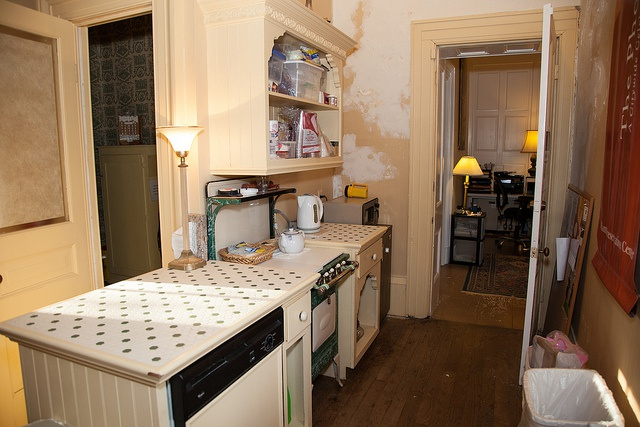Describe the objects in this image and their specific colors. I can see oven in gray and black tones, microwave in gray, black, and maroon tones, chair in gray, black, maroon, and darkgray tones, and bottle in gray, salmon, darkgray, lightgray, and tan tones in this image. 